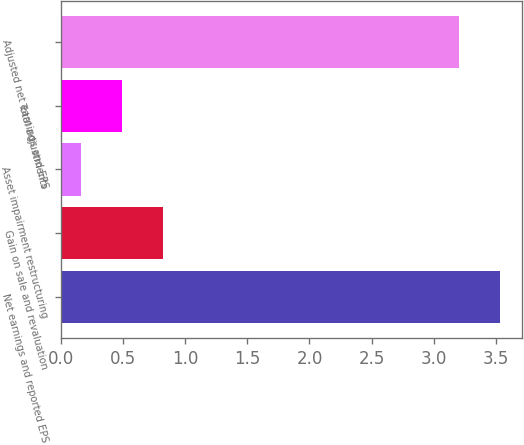Convert chart. <chart><loc_0><loc_0><loc_500><loc_500><bar_chart><fcel>Net earnings and reported EPS<fcel>Gain on sale and revaluation<fcel>Asset impairment restructuring<fcel>Total adjustments<fcel>Adjusted net earnings and EPS<nl><fcel>3.53<fcel>0.82<fcel>0.16<fcel>0.49<fcel>3.2<nl></chart> 